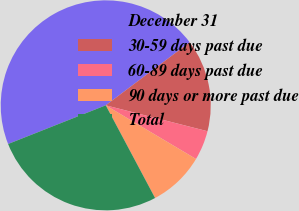Convert chart to OTSL. <chart><loc_0><loc_0><loc_500><loc_500><pie_chart><fcel>December 31<fcel>30-59 days past due<fcel>60-89 days past due<fcel>90 days or more past due<fcel>Total<nl><fcel>45.75%<fcel>14.22%<fcel>4.57%<fcel>8.68%<fcel>26.78%<nl></chart> 